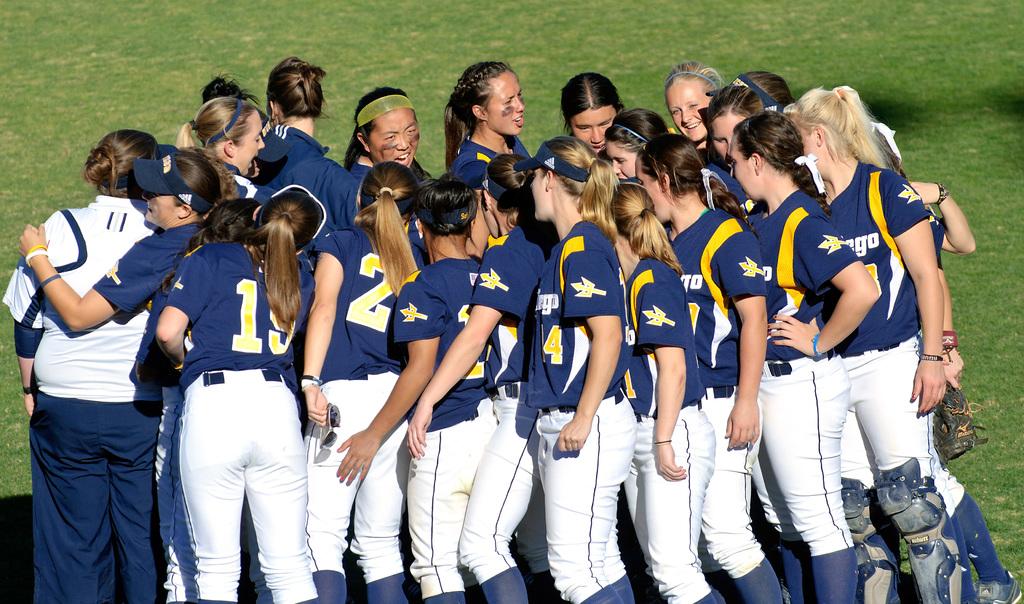What number is the girl on the left shirt?
Make the answer very short. 19. What sport do these girls play?
Your answer should be compact. Softball. 